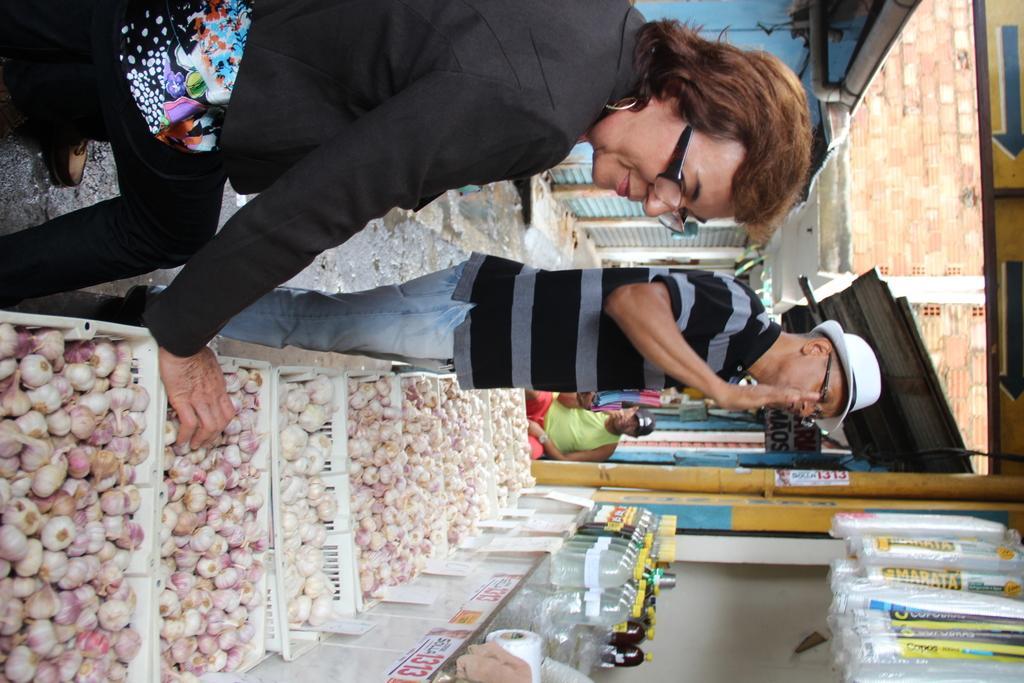How would you summarize this image in a sentence or two? In this picture we can observe a woman near the onions basket. We can observe a person wearing a white color hat. He is standing. Both of them are wearing spectacles. In the background there is another person sitting, wearing black color cap on his head. There are some disposable glasses. We can observe some bottles here. In the background there is a wall. 